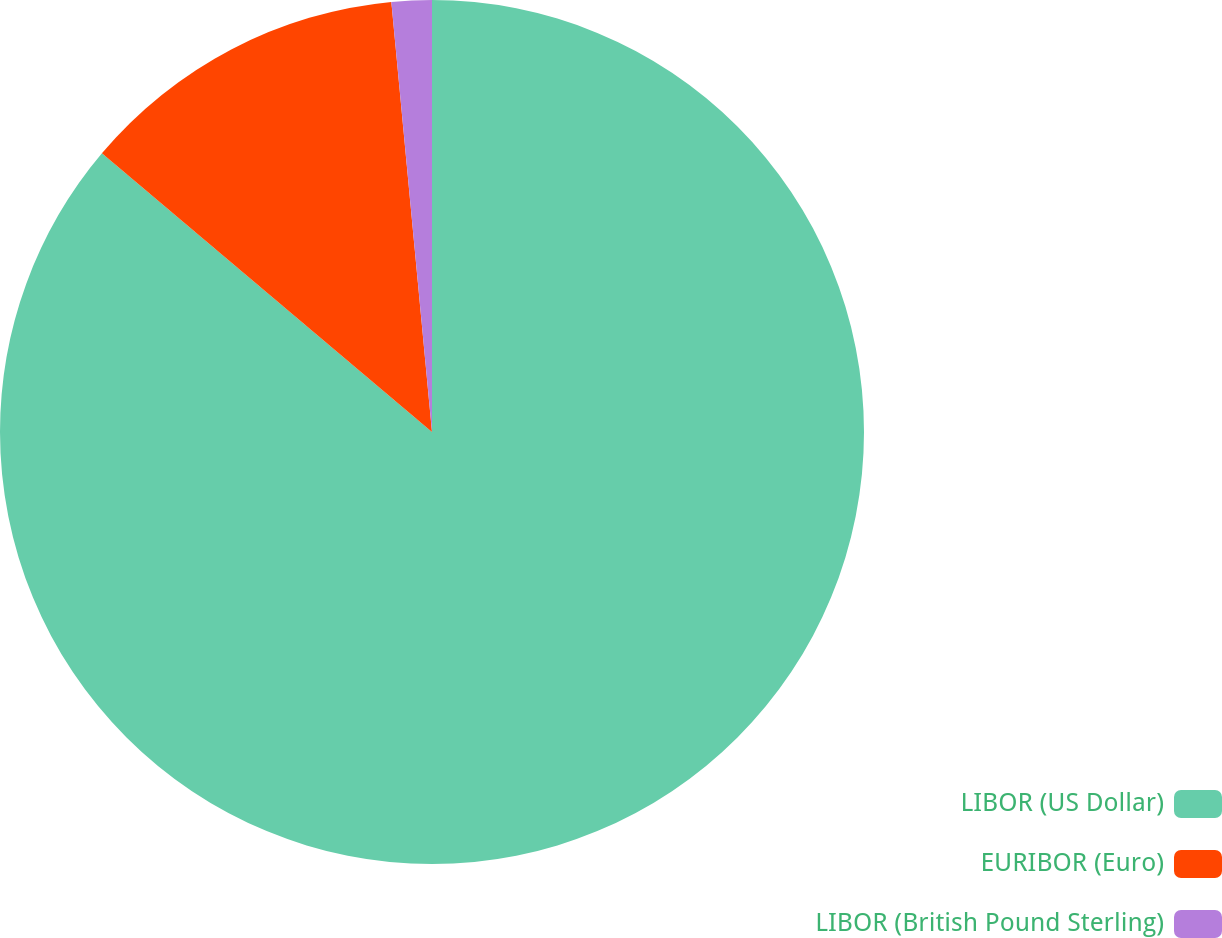Convert chart to OTSL. <chart><loc_0><loc_0><loc_500><loc_500><pie_chart><fcel>LIBOR (US Dollar)<fcel>EURIBOR (Euro)<fcel>LIBOR (British Pound Sterling)<nl><fcel>86.15%<fcel>12.34%<fcel>1.5%<nl></chart> 